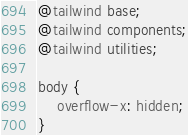<code> <loc_0><loc_0><loc_500><loc_500><_CSS_>@tailwind base;
@tailwind components;
@tailwind utilities;

body {
    overflow-x: hidden;
}</code> 